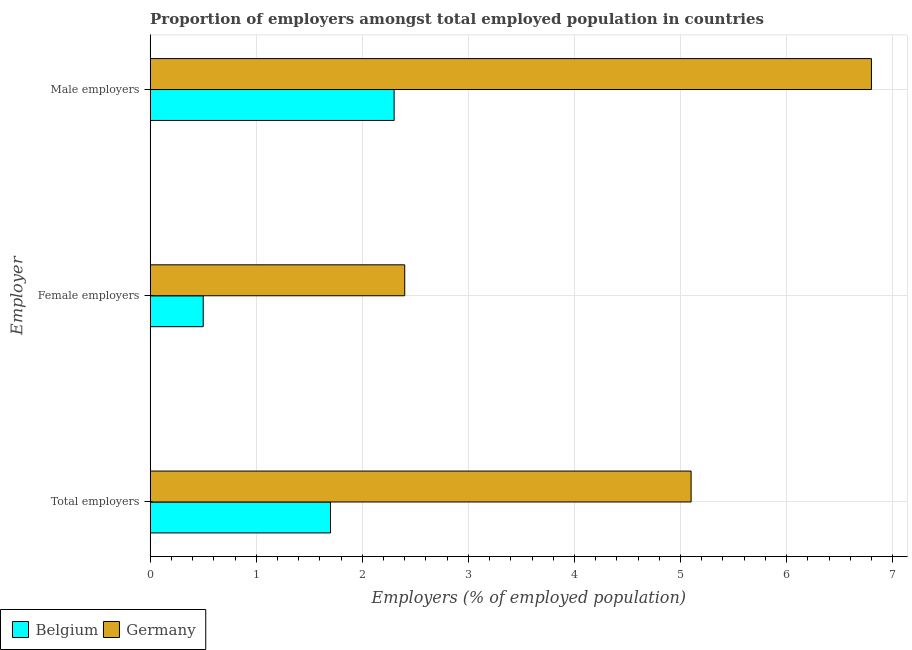What is the label of the 3rd group of bars from the top?
Offer a terse response. Total employers. What is the percentage of male employers in Germany?
Make the answer very short. 6.8. Across all countries, what is the maximum percentage of male employers?
Provide a short and direct response. 6.8. Across all countries, what is the minimum percentage of male employers?
Your answer should be compact. 2.3. What is the total percentage of female employers in the graph?
Provide a short and direct response. 2.9. What is the difference between the percentage of male employers in Belgium and that in Germany?
Your response must be concise. -4.5. What is the difference between the percentage of female employers in Germany and the percentage of male employers in Belgium?
Give a very brief answer. 0.1. What is the average percentage of male employers per country?
Your answer should be compact. 4.55. What is the difference between the percentage of female employers and percentage of male employers in Belgium?
Offer a very short reply. -1.8. What is the ratio of the percentage of total employers in Germany to that in Belgium?
Ensure brevity in your answer.  3. Is the difference between the percentage of male employers in Belgium and Germany greater than the difference between the percentage of female employers in Belgium and Germany?
Your answer should be compact. No. What is the difference between the highest and the second highest percentage of male employers?
Ensure brevity in your answer.  4.5. What is the difference between the highest and the lowest percentage of total employers?
Offer a terse response. 3.4. In how many countries, is the percentage of male employers greater than the average percentage of male employers taken over all countries?
Provide a short and direct response. 1. Is the sum of the percentage of male employers in Belgium and Germany greater than the maximum percentage of total employers across all countries?
Offer a very short reply. Yes. How many countries are there in the graph?
Offer a terse response. 2. Does the graph contain any zero values?
Offer a terse response. No. Does the graph contain grids?
Provide a short and direct response. Yes. How many legend labels are there?
Give a very brief answer. 2. How are the legend labels stacked?
Provide a short and direct response. Horizontal. What is the title of the graph?
Offer a terse response. Proportion of employers amongst total employed population in countries. Does "Austria" appear as one of the legend labels in the graph?
Offer a terse response. No. What is the label or title of the X-axis?
Offer a very short reply. Employers (% of employed population). What is the label or title of the Y-axis?
Provide a short and direct response. Employer. What is the Employers (% of employed population) of Belgium in Total employers?
Your answer should be compact. 1.7. What is the Employers (% of employed population) of Germany in Total employers?
Provide a succinct answer. 5.1. What is the Employers (% of employed population) in Germany in Female employers?
Ensure brevity in your answer.  2.4. What is the Employers (% of employed population) of Belgium in Male employers?
Offer a very short reply. 2.3. What is the Employers (% of employed population) of Germany in Male employers?
Ensure brevity in your answer.  6.8. Across all Employer, what is the maximum Employers (% of employed population) of Belgium?
Provide a short and direct response. 2.3. Across all Employer, what is the maximum Employers (% of employed population) in Germany?
Provide a short and direct response. 6.8. Across all Employer, what is the minimum Employers (% of employed population) of Belgium?
Your answer should be compact. 0.5. Across all Employer, what is the minimum Employers (% of employed population) of Germany?
Your answer should be compact. 2.4. What is the total Employers (% of employed population) in Belgium in the graph?
Make the answer very short. 4.5. What is the difference between the Employers (% of employed population) of Germany in Total employers and that in Female employers?
Your response must be concise. 2.7. What is the difference between the Employers (% of employed population) in Belgium in Female employers and that in Male employers?
Provide a succinct answer. -1.8. What is the difference between the Employers (% of employed population) in Germany in Female employers and that in Male employers?
Ensure brevity in your answer.  -4.4. What is the average Employers (% of employed population) of Belgium per Employer?
Give a very brief answer. 1.5. What is the average Employers (% of employed population) of Germany per Employer?
Make the answer very short. 4.77. What is the difference between the Employers (% of employed population) in Belgium and Employers (% of employed population) in Germany in Female employers?
Your answer should be compact. -1.9. What is the ratio of the Employers (% of employed population) in Germany in Total employers to that in Female employers?
Your answer should be compact. 2.12. What is the ratio of the Employers (% of employed population) of Belgium in Total employers to that in Male employers?
Your answer should be compact. 0.74. What is the ratio of the Employers (% of employed population) in Belgium in Female employers to that in Male employers?
Your answer should be compact. 0.22. What is the ratio of the Employers (% of employed population) in Germany in Female employers to that in Male employers?
Provide a short and direct response. 0.35. What is the difference between the highest and the second highest Employers (% of employed population) of Belgium?
Ensure brevity in your answer.  0.6. What is the difference between the highest and the second highest Employers (% of employed population) of Germany?
Ensure brevity in your answer.  1.7. What is the difference between the highest and the lowest Employers (% of employed population) of Belgium?
Keep it short and to the point. 1.8. 